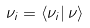<formula> <loc_0><loc_0><loc_500><loc_500>\nu _ { i } = \left \langle \nu _ { i } \right | \nu \rangle</formula> 